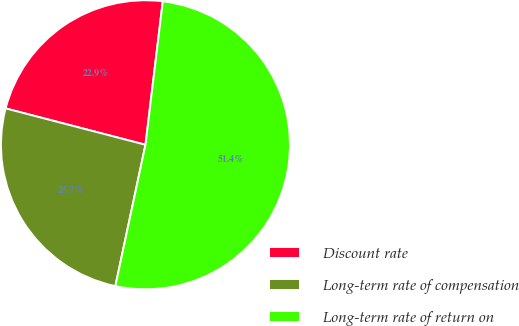Convert chart. <chart><loc_0><loc_0><loc_500><loc_500><pie_chart><fcel>Discount rate<fcel>Long-term rate of compensation<fcel>Long-term rate of return on<nl><fcel>22.86%<fcel>25.71%<fcel>51.43%<nl></chart> 